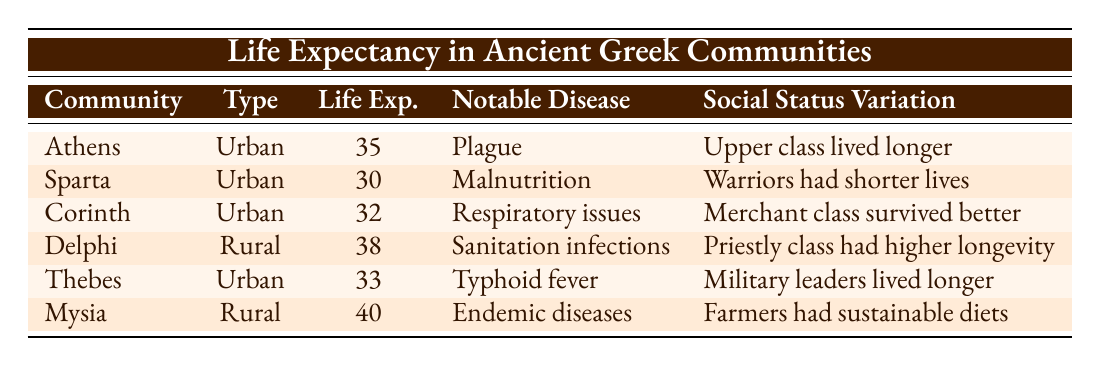What is the average life expectancy in urban communities in ancient Greece? The urban life expectancies listed in the table are 35 (Athens), 30 (Sparta), 32 (Corinth), and 33 (Thebes). To find the average, we sum these values: 35 + 30 + 32 + 33 = 130. There are 4 urban communities, so the average life expectancy is 130 / 4 = 32.5.
Answer: 32.5 Which community has the highest life expectancy? Looking at the average life expectancies, Delphi has 38, and Mysia has 40. Since 40 is greater than 38, Mysia has the highest life expectancy in the data provided.
Answer: Mysia Is it true that the upper class in Athens had a longer life expectancy due to better access to resources? The table indicates that in Athens, the upper class lived longer, which suggests that better access to resources did influence life expectancy positively for this social group. Therefore, the statement is true.
Answer: Yes What is the difference in life expectancy between the rural community of Delphi and the urban community of Athens? Delphi has an average life expectancy of 38, while Athens has 35. To find the difference, we subtract Athens's life expectancy from Delphi's: 38 - 35 = 3.
Answer: 3 Which community is noted for having a notable disease related to military training? The table states that Sparta's notable disease is related to malnutrition from military training. Therefore, the community associated with this disease is Sparta.
Answer: Sparta Calculate the total life expectancy of all communities listed in the table. The average life expectancies in the table are 35 (Athens), 30 (Sparta), 32 (Corinth), 38 (Delphi), 33 (Thebes), and 40 (Mysia). Summing these values, we have 35 + 30 + 32 + 38 + 33 + 40 = 208.
Answer: 208 Is It true that farmers had a more sustainable diet compared to urban workers? According to the data, Mysia's social status variation mentions that farmers had a more sustainable diet compared to urban workers, indicating that this statement is true.
Answer: Yes What is the average life expectancy of rural communities in ancient Greece? The life expectancies for rural communities in the table are 38 (Delphi) and 40 (Mysia). The total is 38 + 40 = 78, and since there are 2 rural communities, we calculate the average as 78 / 2 = 39.
Answer: 39 